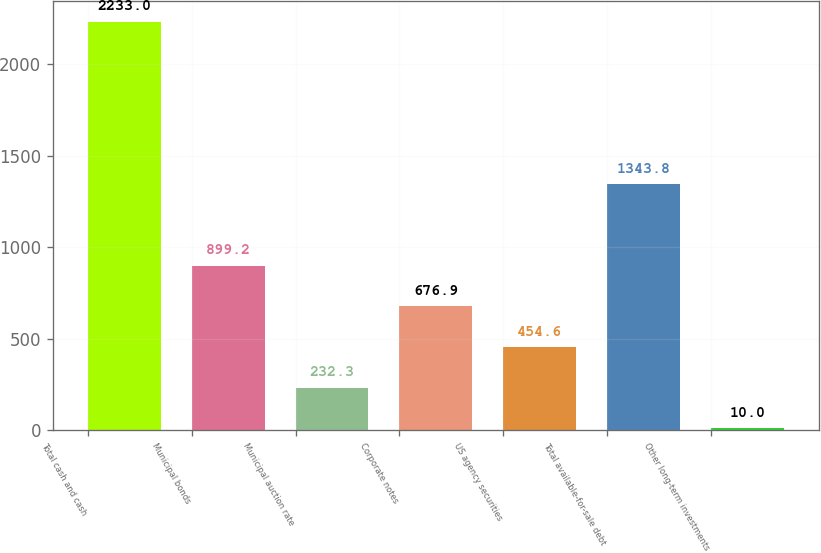Convert chart. <chart><loc_0><loc_0><loc_500><loc_500><bar_chart><fcel>Total cash and cash<fcel>Municipal bonds<fcel>Municipal auction rate<fcel>Corporate notes<fcel>US agency securities<fcel>Total available-for-sale debt<fcel>Other long-term investments<nl><fcel>2233<fcel>899.2<fcel>232.3<fcel>676.9<fcel>454.6<fcel>1343.8<fcel>10<nl></chart> 